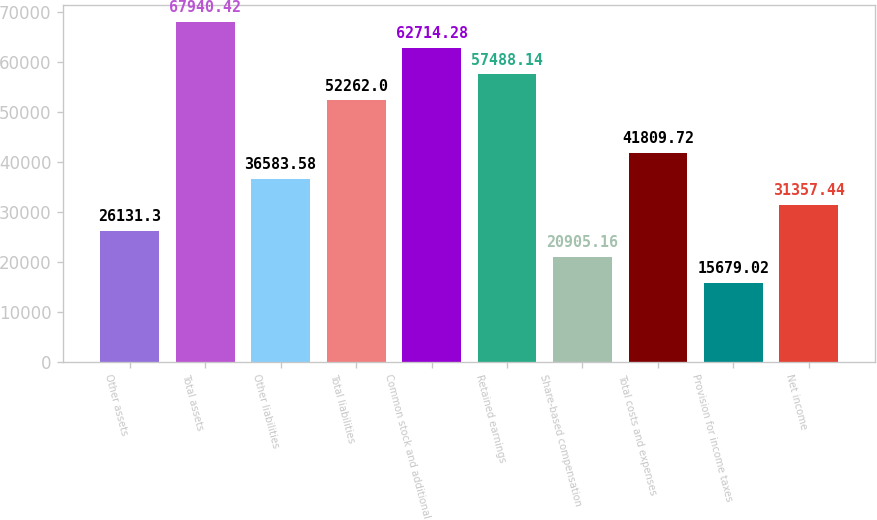Convert chart. <chart><loc_0><loc_0><loc_500><loc_500><bar_chart><fcel>Other assets<fcel>Total assets<fcel>Other liabilities<fcel>Total liabilities<fcel>Common stock and additional<fcel>Retained earnings<fcel>Share-based compensation<fcel>Total costs and expenses<fcel>Provision for income taxes<fcel>Net income<nl><fcel>26131.3<fcel>67940.4<fcel>36583.6<fcel>52262<fcel>62714.3<fcel>57488.1<fcel>20905.2<fcel>41809.7<fcel>15679<fcel>31357.4<nl></chart> 